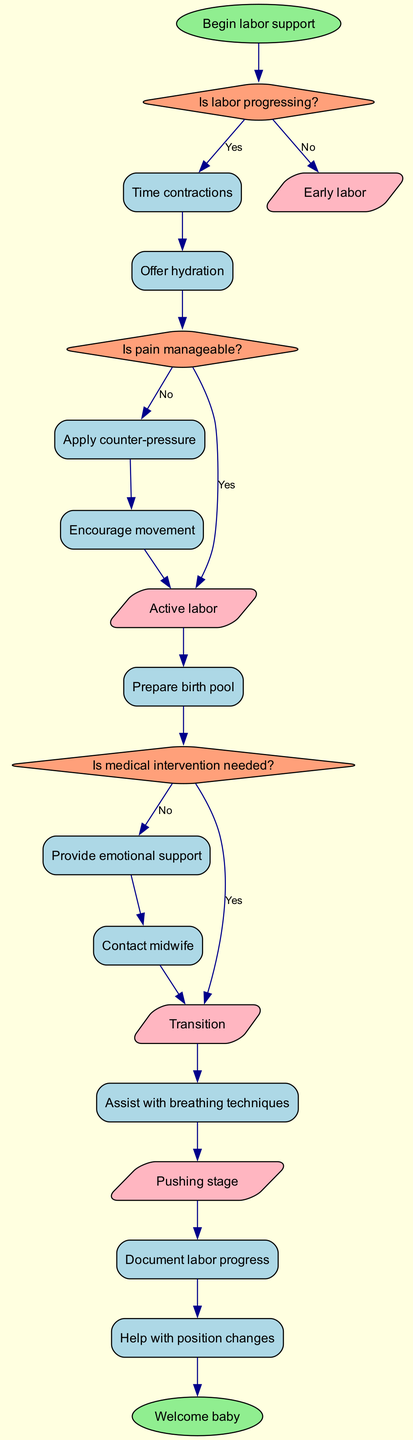What is the first node in the diagram? The first node is labeled "Begin labor support," which is the starting point of the flowchart, representing the initiation of the partner's role during labor.
Answer: Begin labor support How many actions are listed in the diagram? The diagram includes ten actions that the partner can take during labor, providing various forms of support to the laboring person.
Answer: 10 What is the last node in the diagram? The last node is labeled "Welcome baby," which signifies the end of the labor support flow, indicating the successful arrival of the newborn.
Answer: Welcome baby What is the label of the decision point following "Is labor progressing?" The next decision point, following "Is labor progressing?", is "Is pain manageable?", which assesses the partner's role in addressing the laboring person's comfort levels.
Answer: Is pain manageable? What happens if pain is manageable according to the diagram? If pain is manageable (answering "Yes" to the decision point), the next action is to prepare the birth pool, indicating a step the partner takes based on the comfort level of the laboring person.
Answer: Prepare birth pool How does the flow transition from "Early labor" to the next stage? Transitioning from "Early labor," if labor is not progressing, the flow moves to actions such as timing contractions and offering hydration before potentially transitioning to "Active labor" based on the decisions made.
Answer: Active labor What action follows after "Help with position changes"? The action that follows "Help with position changes" is "Document labor progress," indicating the importance of recording the labor's development for reference and communication with the midwife.
Answer: Document labor progress What happens if medical intervention is needed? If the decision point "Is medical intervention needed?" is answered with "Yes," the flow redirects to contacting the midwife, ensuring professional assistance is provided promptly.
Answer: Contact midwife What shapes are used for decision points in the diagram? The decision points in the diagram are represented by diamonds, a common shape indicating branching paths based on yes/no questions or conditions.
Answer: Diamonds What stage is directly after "Transition"? After the "Transition" stage, the flowchart identifies the "Pushing stage," illustrating the labor process as it progresses toward the goal of childbirth.
Answer: Pushing stage 